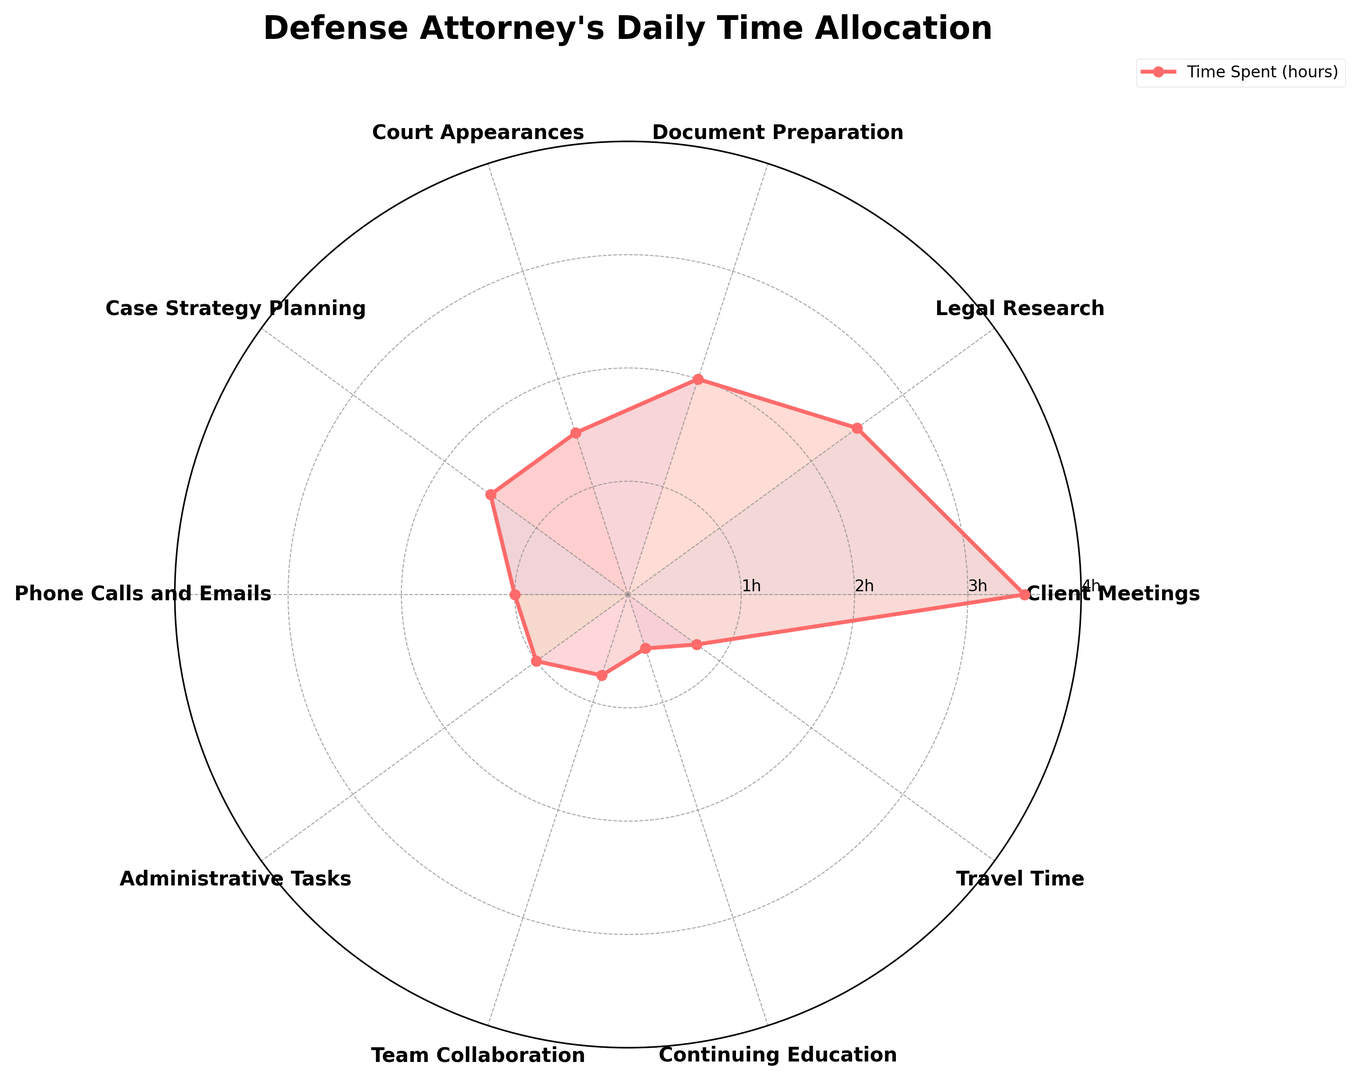Which task takes up the most time in the defense attorney's daily schedule? By examining the lengths of the visual elements extending outward from the center of the radar chart, it's clear that the segment for "Client Meetings" extends the furthest, indicating it takes the most hours.
Answer: Client Meetings What is the total amount of time spent on Court Appearances and Case Strategy Planning combined? Looking at the figure, the hours spent on Court Appearances and Case Strategy Planning are both visually indicated at 1.5 hours each. Summing these values gives 1.5 + 1.5 = 3 hours.
Answer: 3 hours Which task requires equal time allocation as Administrative Tasks? The radar chart shows that the visual element for "Administrative Tasks" (1 hour) matches in length with the segment for "Phone Calls and Emails" indicating they require equal time.
Answer: Phone Calls and Emails How does the time spent on Legal Research compare to Document Preparation? The radar chart visibly shows that the segment for "Legal Research" (2.5 hours) extends further than the one for "Document Preparation" (2 hours), indicating more time is spent on Legal Research.
Answer: Legal Research takes more time What is the average time spent on Administrative Tasks, Team Collaboration, and Continuing Education? The chart shows 1 hour for Administrative Tasks, 0.75 hours for Team Collaboration, and 0.5 hours for Continuing Education. Summing these gives: 1.0 + 0.75 + 0.5 = 2.25 hours. Dividing by 3 (the number of tasks) gives 2.25/3 = 0.75 hours.
Answer: 0.75 hours Which task takes less than 1 hour but more than half an hour? The visual segments for tasks under 1 hour show only "Team Collaboration" at 0.75 hours fitting the criteria of more than 0.5 and less than 1 hour.
Answer: Team Collaboration What is the difference in time spent between Client Meetings and Travel Time? The chart shows 3.5 hours for Client Meetings and 0.75 hours for Travel Time. Subtraction: 3.5 - 0.75 = 2.75 hours.
Answer: 2.75 hours How much time in total is dedicated to Travel Time and Phone Calls and Emails? The radar segments for Travel Time and Phone Calls and Emails show 0.75 hours and 1.0 hour respectively. Summing these gives: 0.75 + 1.0 = 1.75 hours.
Answer: 1.75 hours 